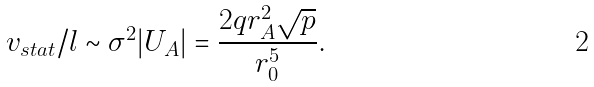Convert formula to latex. <formula><loc_0><loc_0><loc_500><loc_500>v _ { s t a t } / l \sim \sigma ^ { 2 } | U _ { A } | = { \frac { 2 q r _ { A } ^ { 2 } \sqrt { p } } { r _ { 0 } ^ { 5 } } } .</formula> 